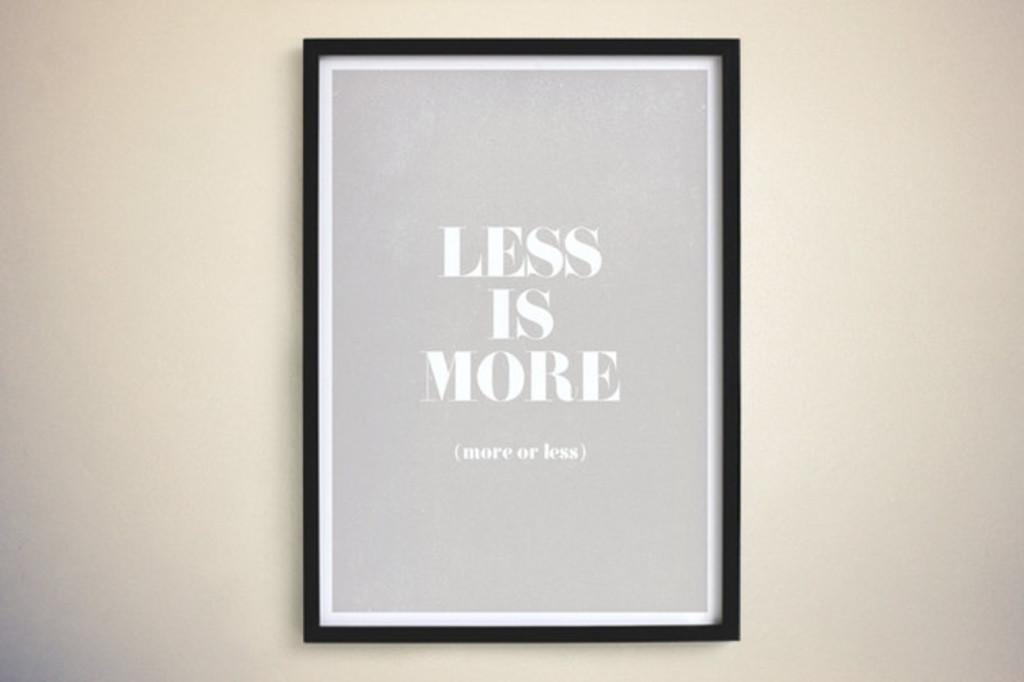<image>
Describe the image concisely. a photo of words that say less is more 